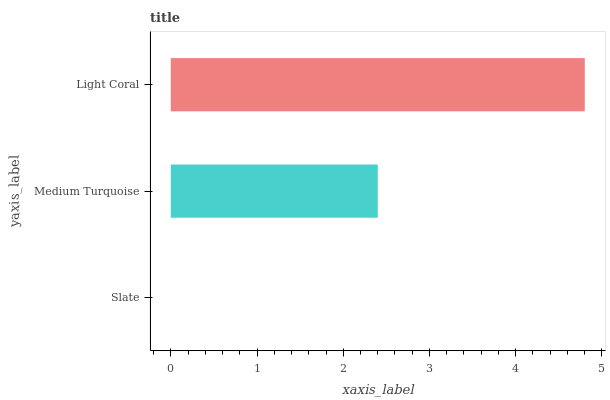Is Slate the minimum?
Answer yes or no. Yes. Is Light Coral the maximum?
Answer yes or no. Yes. Is Medium Turquoise the minimum?
Answer yes or no. No. Is Medium Turquoise the maximum?
Answer yes or no. No. Is Medium Turquoise greater than Slate?
Answer yes or no. Yes. Is Slate less than Medium Turquoise?
Answer yes or no. Yes. Is Slate greater than Medium Turquoise?
Answer yes or no. No. Is Medium Turquoise less than Slate?
Answer yes or no. No. Is Medium Turquoise the high median?
Answer yes or no. Yes. Is Medium Turquoise the low median?
Answer yes or no. Yes. Is Slate the high median?
Answer yes or no. No. Is Light Coral the low median?
Answer yes or no. No. 